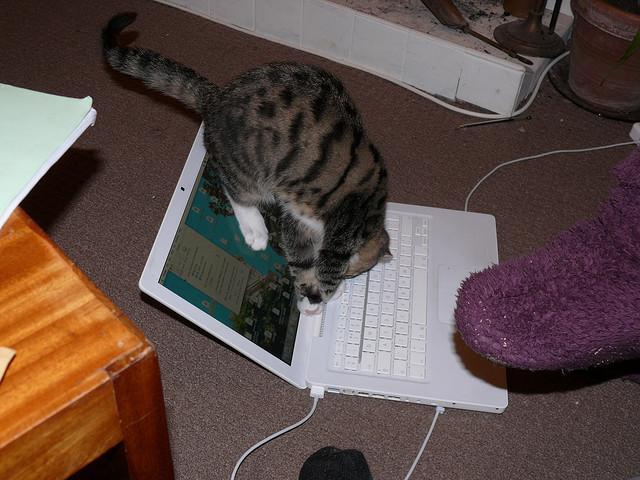How many shoes are there?
Give a very brief answer. 1. 